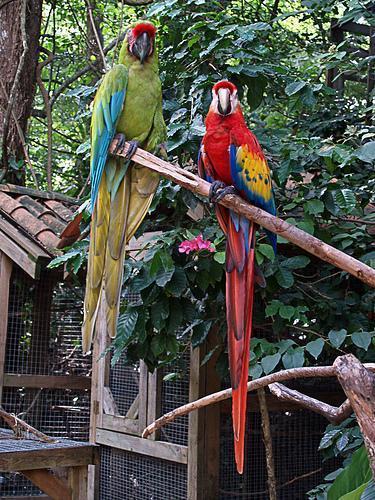How many parrots are there?
Give a very brief answer. 2. 